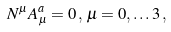Convert formula to latex. <formula><loc_0><loc_0><loc_500><loc_500>N ^ { \mu } A _ { \mu } ^ { a } = 0 \, , \, \mu = 0 , \dots 3 \, ,</formula> 